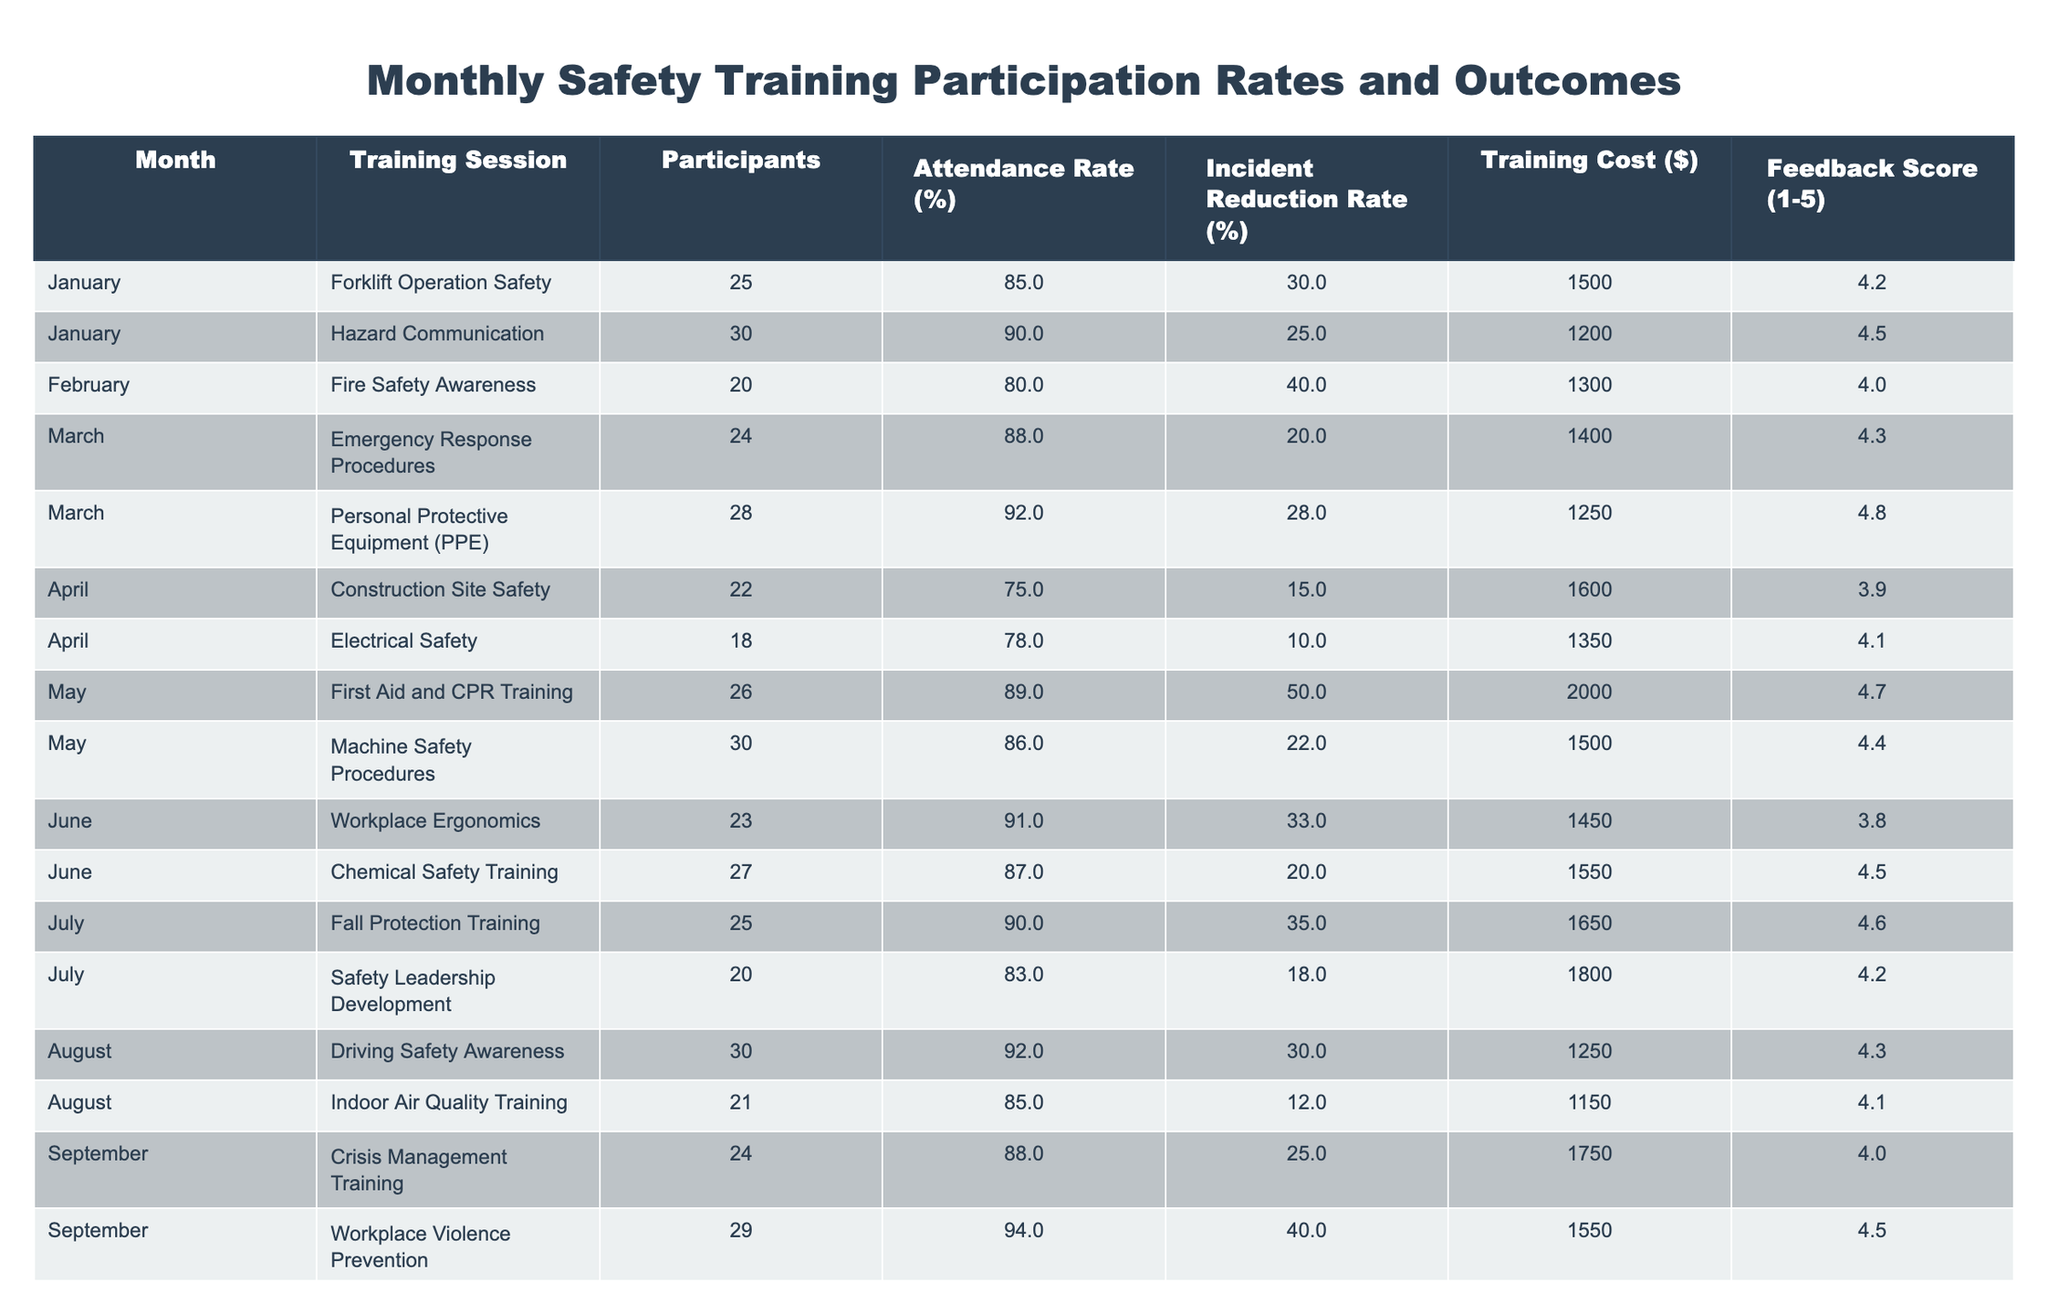What was the attendance rate for the "First Aid and CPR Training" session in May? According to the table, the attendance rate for the "First Aid and CPR Training" session in May is listed as 89%.
Answer: 89% Which training session in September had the highest incident reduction rate? In September, the "Workplace Violence Prevention" training had the highest incident reduction rate at 40% compared to the "Crisis Management Training," which had 25%.
Answer: Workplace Violence Prevention What is the average attendance rate across all training sessions held in March? To find the average attendance rate for March, we add the attendance rates of both sessions: 88% (Emergency Response Procedures) + 92% (Personal Protective Equipment) = 180%. This sum is divided by 2 sessions, yielding an average attendance rate of 90%.
Answer: 90% Was the training cost for "Electrical Safety" higher than that for "Fall Protection Training"? The training cost for "Electrical Safety" was $1350, while "Fall Protection Training" cost $1650. Since $1350 is less than $1650, the statement is false.
Answer: No What month had the highest overall feedback score from training sessions? The highest feedback score in the table is 4.8 from the "Personal Protective Equipment" session in March. None of the other months had a higher score than this. Therefore, March is the month with the highest overall feedback score.
Answer: March Calculate the total training cost for all sessions conducted in June. To find the total training cost for June, we sum the costs of both sessions: $1450 (Workplace Ergonomics) + $1550 (Chemical Safety Training) = $3000. Therefore, the total training cost for June is $3000.
Answer: $3000 Which training session had the lowest feedback score, and what was the score? From the table, the "Construction Site Safety" session in April had the lowest feedback score of 3.9 among all training sessions listed.
Answer: Construction Site Safety, 3.9 Did all training sessions achieve an attendance rate of at least 80%? By reviewing the attendance rates in the table, the sessions "Construction Site Safety" (75%) and "Electrical Safety" (78%) did not meet the 80% threshold. Therefore, not all sessions achieved this.
Answer: No 